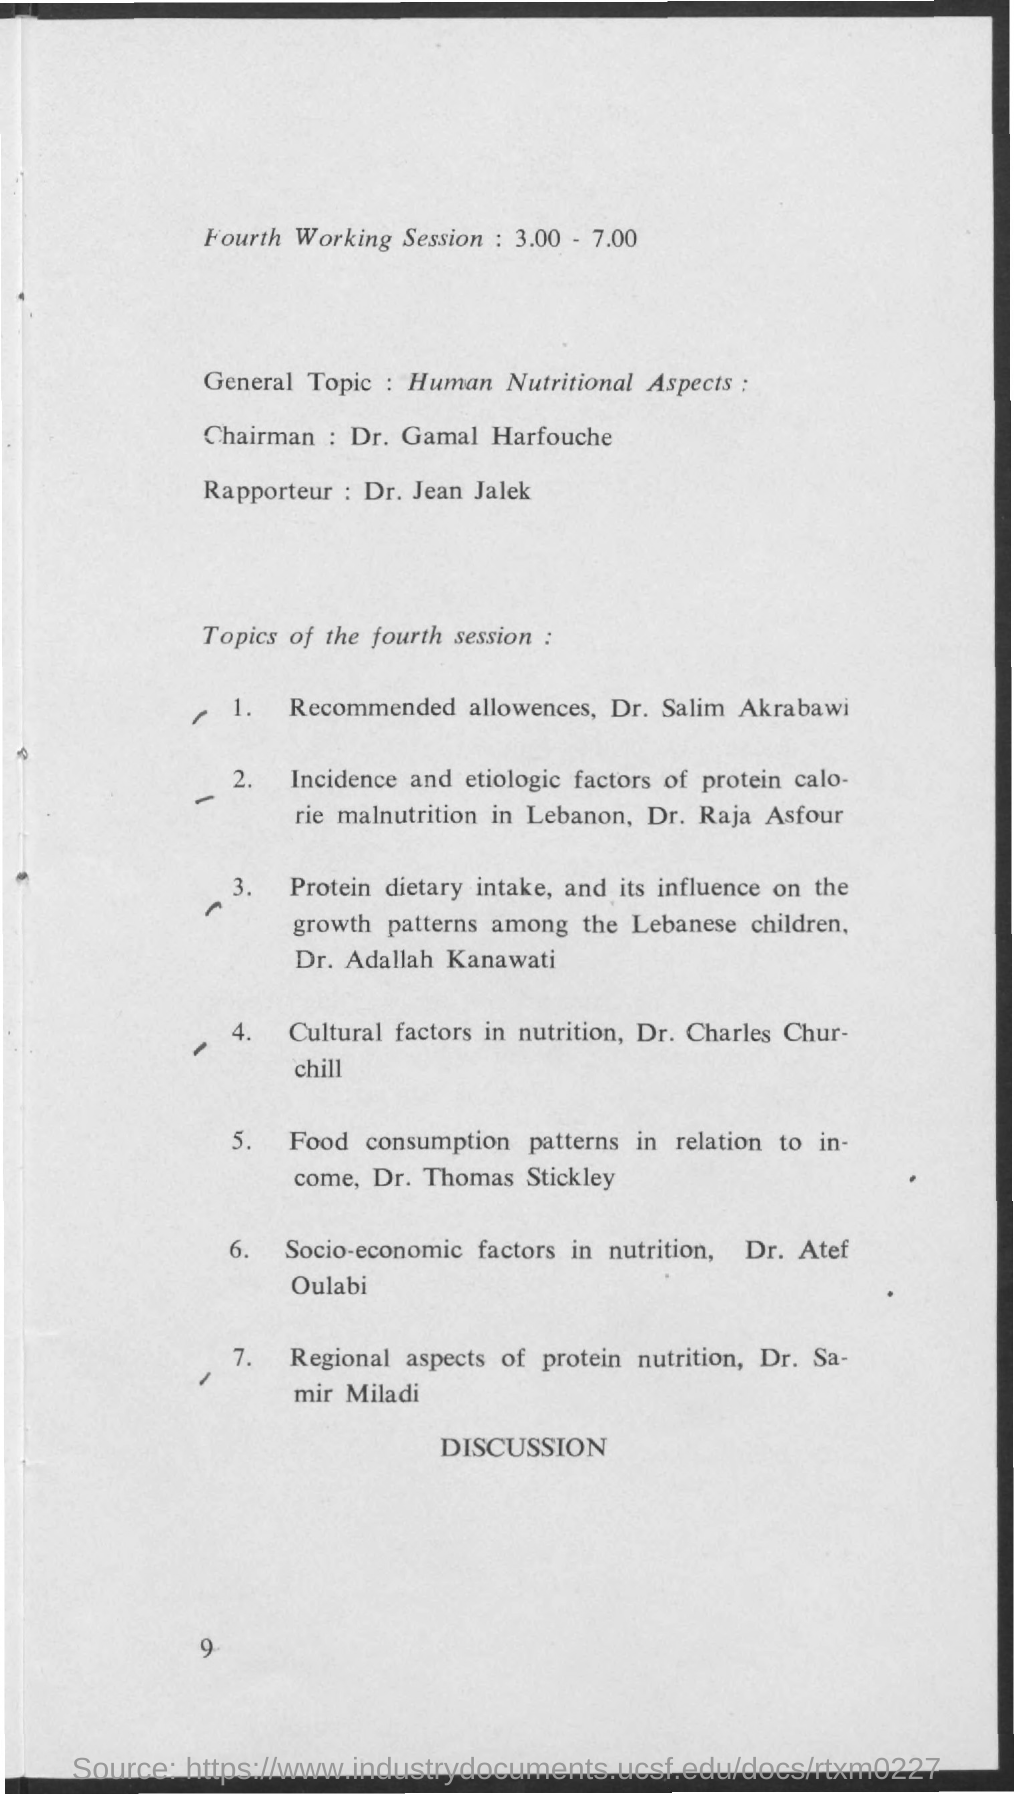What is the time of fourth working session mentioned ?
Provide a succinct answer. 3.00 - 7.00. What is the general topic mentioned ?
Provide a short and direct response. Human Nutritional Aspects. What is the name of chairman mentioned ?
Provide a succinct answer. Dr. Gamal Harfouche. 